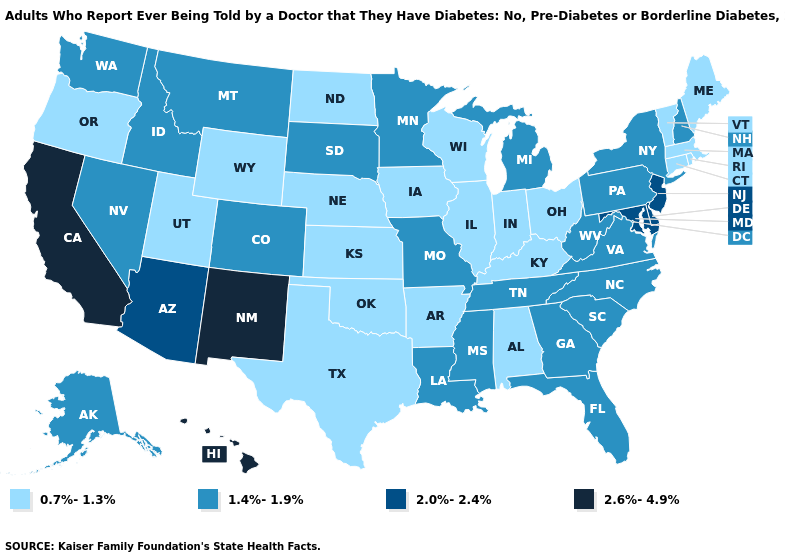What is the value of Massachusetts?
Give a very brief answer. 0.7%-1.3%. What is the value of New Hampshire?
Short answer required. 1.4%-1.9%. Is the legend a continuous bar?
Write a very short answer. No. Which states have the lowest value in the USA?
Give a very brief answer. Alabama, Arkansas, Connecticut, Illinois, Indiana, Iowa, Kansas, Kentucky, Maine, Massachusetts, Nebraska, North Dakota, Ohio, Oklahoma, Oregon, Rhode Island, Texas, Utah, Vermont, Wisconsin, Wyoming. What is the highest value in the USA?
Short answer required. 2.6%-4.9%. Does the first symbol in the legend represent the smallest category?
Concise answer only. Yes. What is the value of New Jersey?
Quick response, please. 2.0%-2.4%. Is the legend a continuous bar?
Keep it brief. No. What is the highest value in the USA?
Be succinct. 2.6%-4.9%. Name the states that have a value in the range 2.0%-2.4%?
Be succinct. Arizona, Delaware, Maryland, New Jersey. Does Connecticut have the lowest value in the USA?
Short answer required. Yes. What is the value of Virginia?
Give a very brief answer. 1.4%-1.9%. Which states hav the highest value in the Northeast?
Be succinct. New Jersey. Does the first symbol in the legend represent the smallest category?
Write a very short answer. Yes. Does Massachusetts have the lowest value in the USA?
Concise answer only. Yes. 